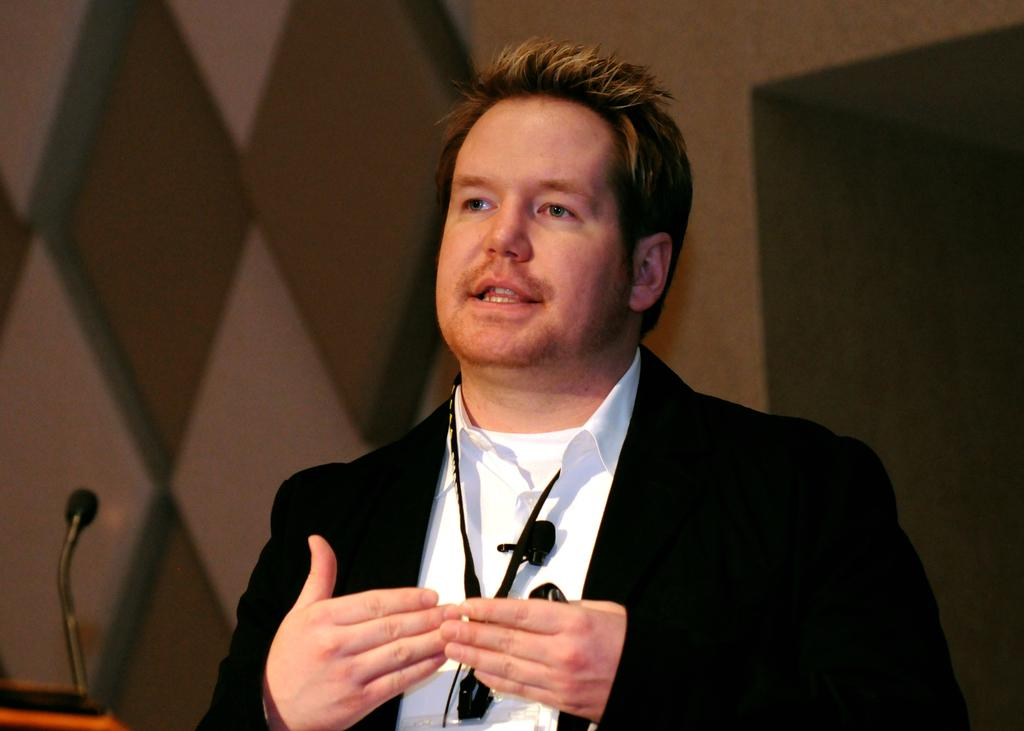Who or what is the main subject in the image? There is a person in the image. What is the person wearing? The person is wearing a blazer. What can be seen in the background of the image? There is a wall in the background of the image. What object is present that might be used for speaking or recording? There is a microphone in the image. How many beginner books can be seen on the person's desk in the image? There is no desk or books present in the image. What type of steps are visible in the image? There are no steps visible in the image. 